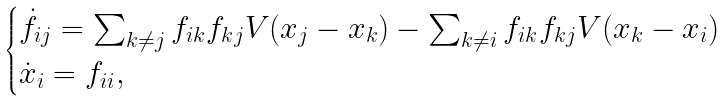<formula> <loc_0><loc_0><loc_500><loc_500>\begin{cases} \dot { f } _ { i j } = \sum _ { k \ne j } f _ { i k } f _ { k j } V ( x _ { j } - x _ { k } ) - \sum _ { k \ne i } f _ { i k } f _ { k j } V ( x _ { k } - x _ { i } ) \\ \dot { x } _ { i } = f _ { i i } , \end{cases}</formula> 